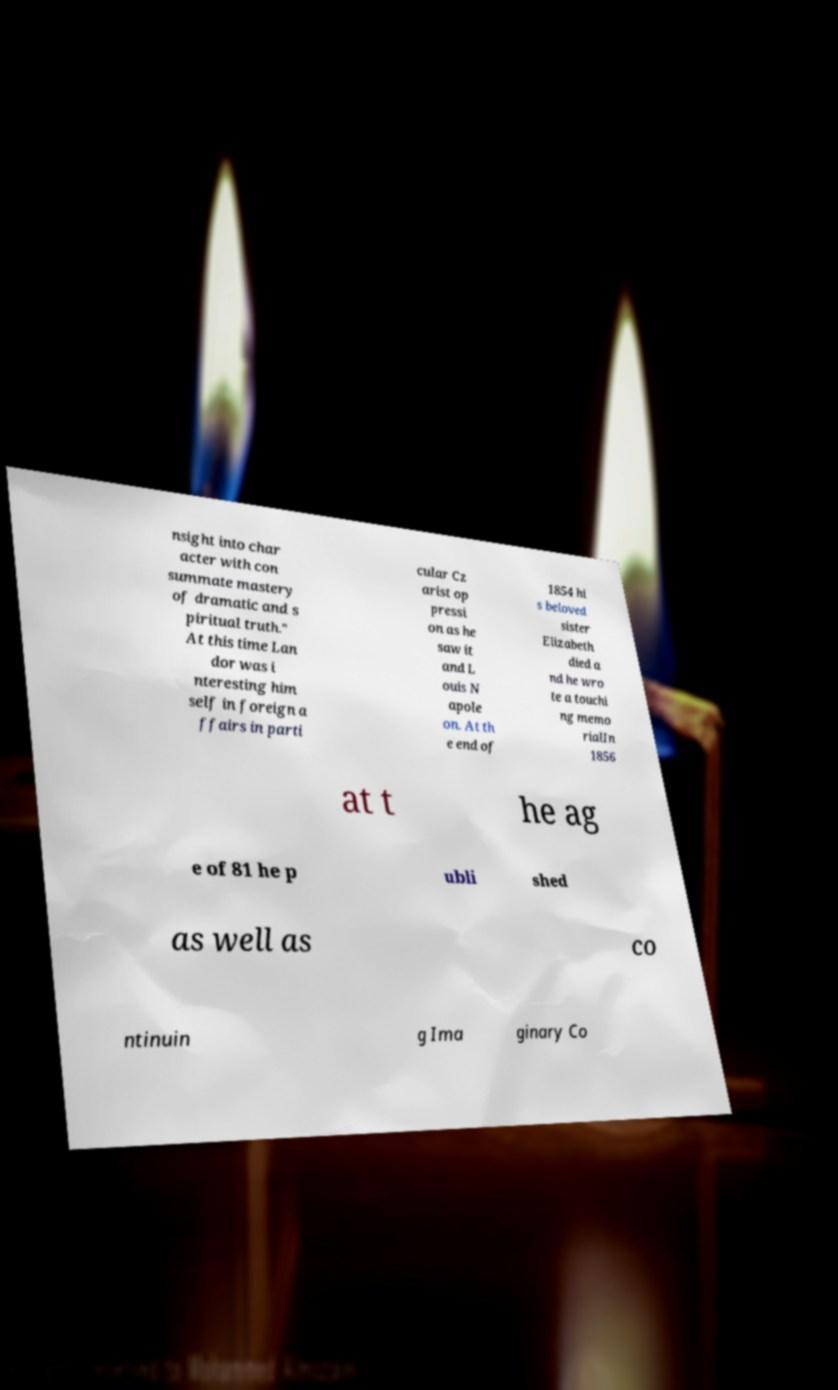Please read and relay the text visible in this image. What does it say? nsight into char acter with con summate mastery of dramatic and s piritual truth." At this time Lan dor was i nteresting him self in foreign a ffairs in parti cular Cz arist op pressi on as he saw it and L ouis N apole on. At th e end of 1854 hi s beloved sister Elizabeth died a nd he wro te a touchi ng memo rialIn 1856 at t he ag e of 81 he p ubli shed as well as co ntinuin g Ima ginary Co 